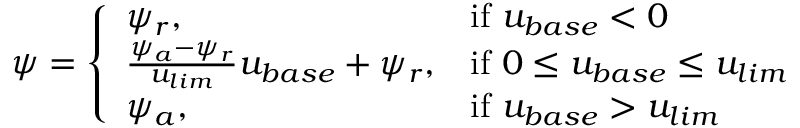Convert formula to latex. <formula><loc_0><loc_0><loc_500><loc_500>\psi = \left \{ \begin{array} { l l } { \psi _ { r } , } & { i f u _ { b a s e } < 0 } \\ { \frac { \psi _ { a } - \psi _ { r } } { u _ { l i m } } u _ { b a s e } + \psi _ { r } , } & { i f 0 \leq u _ { b a s e } \leq u _ { l i m } } \\ { \psi _ { a } , } & { i f u _ { b a s e } > u _ { l i m } } \end{array}</formula> 